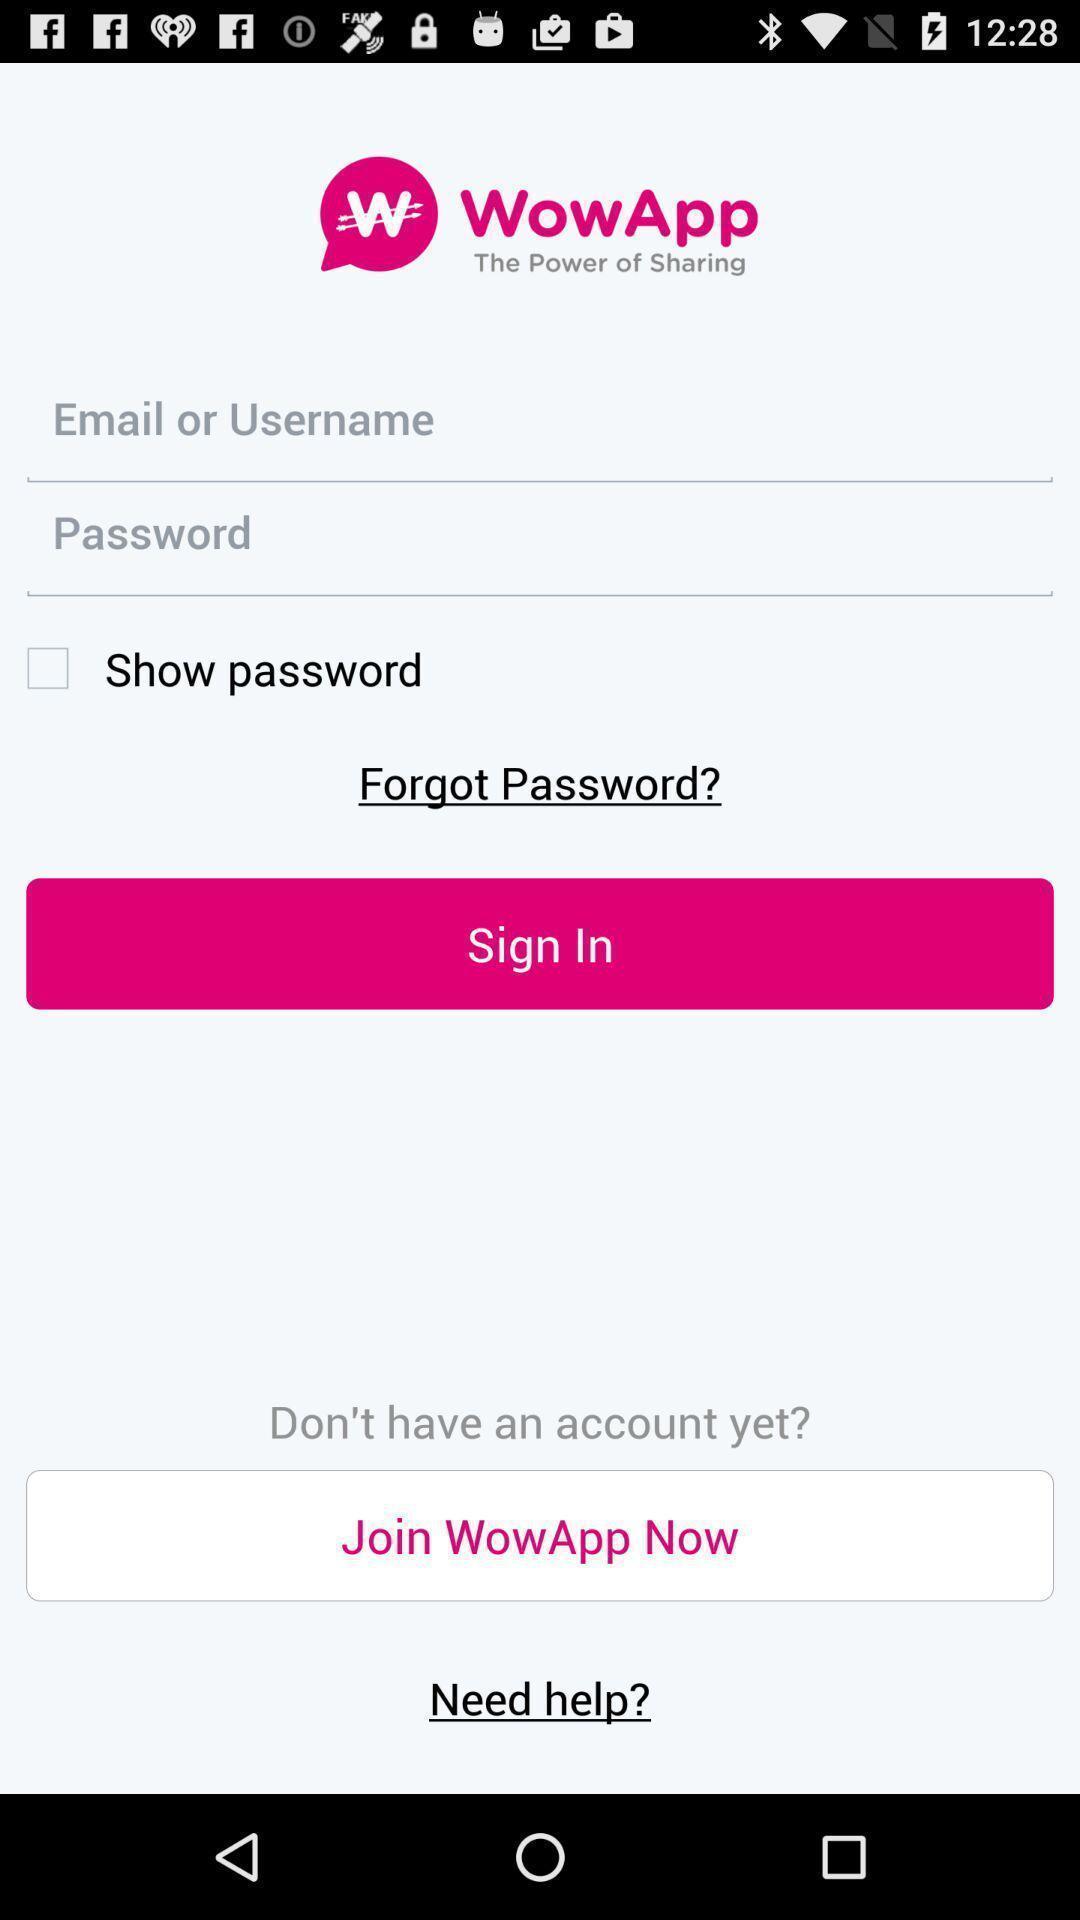Provide a description of this screenshot. Sign in page. 